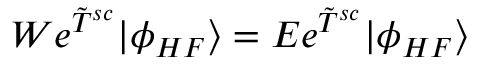Convert formula to latex. <formula><loc_0><loc_0><loc_500><loc_500>W e ^ { \tilde { T } ^ { s c } } | \phi _ { H F } \rangle = E e ^ { \tilde { T } ^ { s c } } | \phi _ { H F } \rangle</formula> 